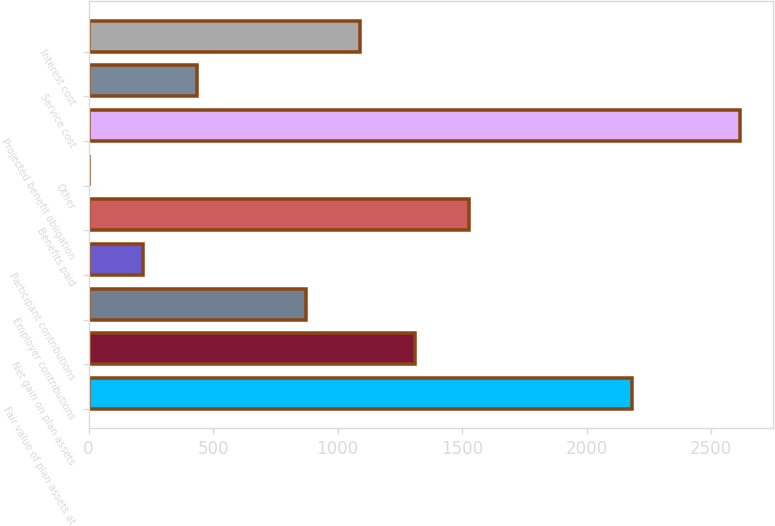Convert chart to OTSL. <chart><loc_0><loc_0><loc_500><loc_500><bar_chart><fcel>Fair value of plan assets at<fcel>Net gain on plan assets<fcel>Employer contributions<fcel>Participant contributions<fcel>Benefits paid<fcel>Other<fcel>Projected benefit obligation<fcel>Service cost<fcel>Interest cost<nl><fcel>2181<fcel>1309<fcel>873<fcel>219<fcel>1527<fcel>1<fcel>2617<fcel>437<fcel>1091<nl></chart> 